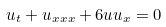Convert formula to latex. <formula><loc_0><loc_0><loc_500><loc_500>u _ { t } + u _ { x x x } + 6 u u _ { x } = 0</formula> 